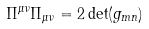<formula> <loc_0><loc_0><loc_500><loc_500>\Pi ^ { \mu \nu } \Pi _ { \mu \nu } = 2 \det ( g _ { m n } )</formula> 